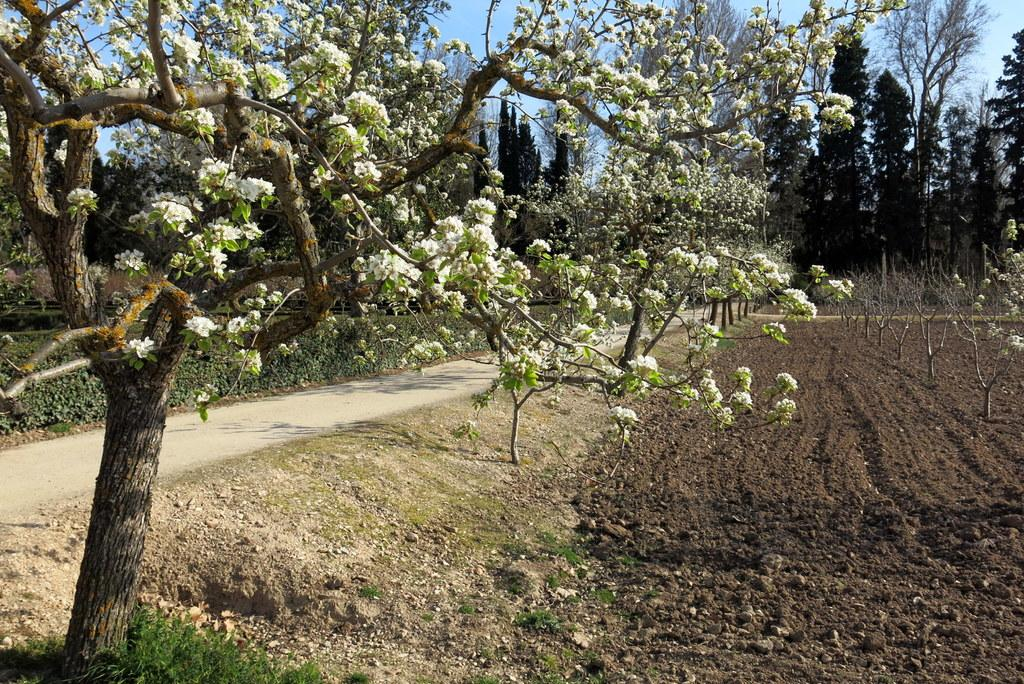What type of tree is present in the image? There is a tree with white flowers in the image. What is located near the tree? There is a road beside the tree. What can be seen in the background of the image? There are trees in the background of the image. What type of pen is visible on the tree in the image? There is no pen present on the tree in the image. How does the car interact with the tree in the image? There is no car present in the image, so it cannot interact with the tree. 